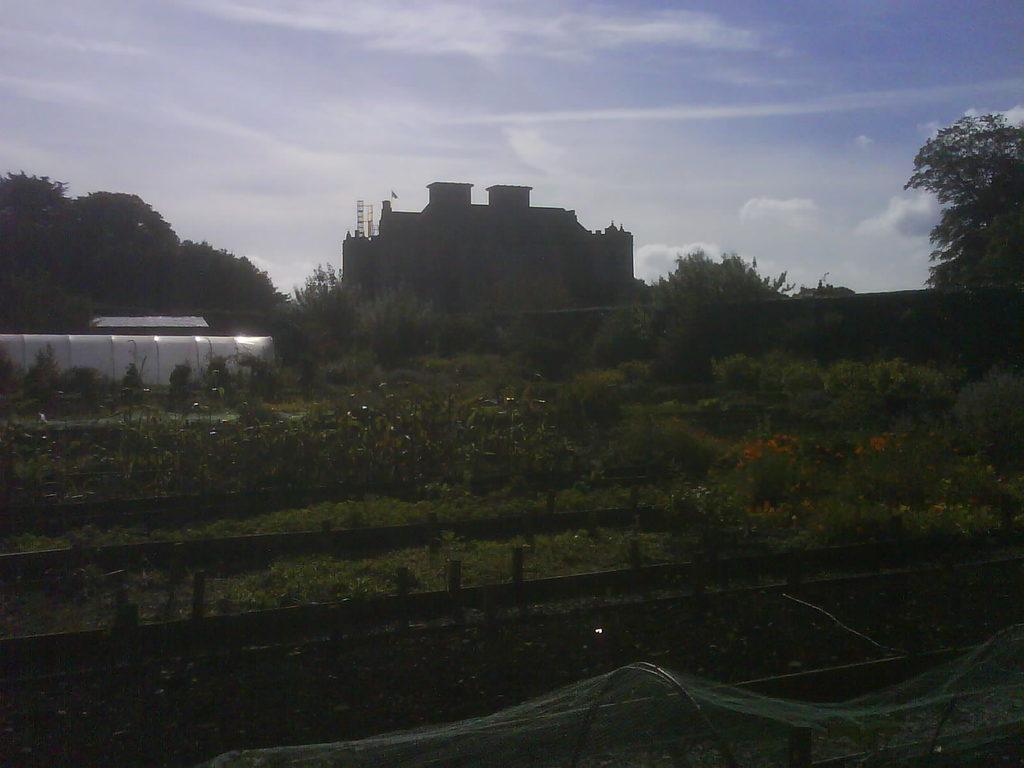In one or two sentences, can you explain what this image depicts? In this picture I can see grass, plants, flowers, there is a building, there are trees, and in the background there is the sky. 